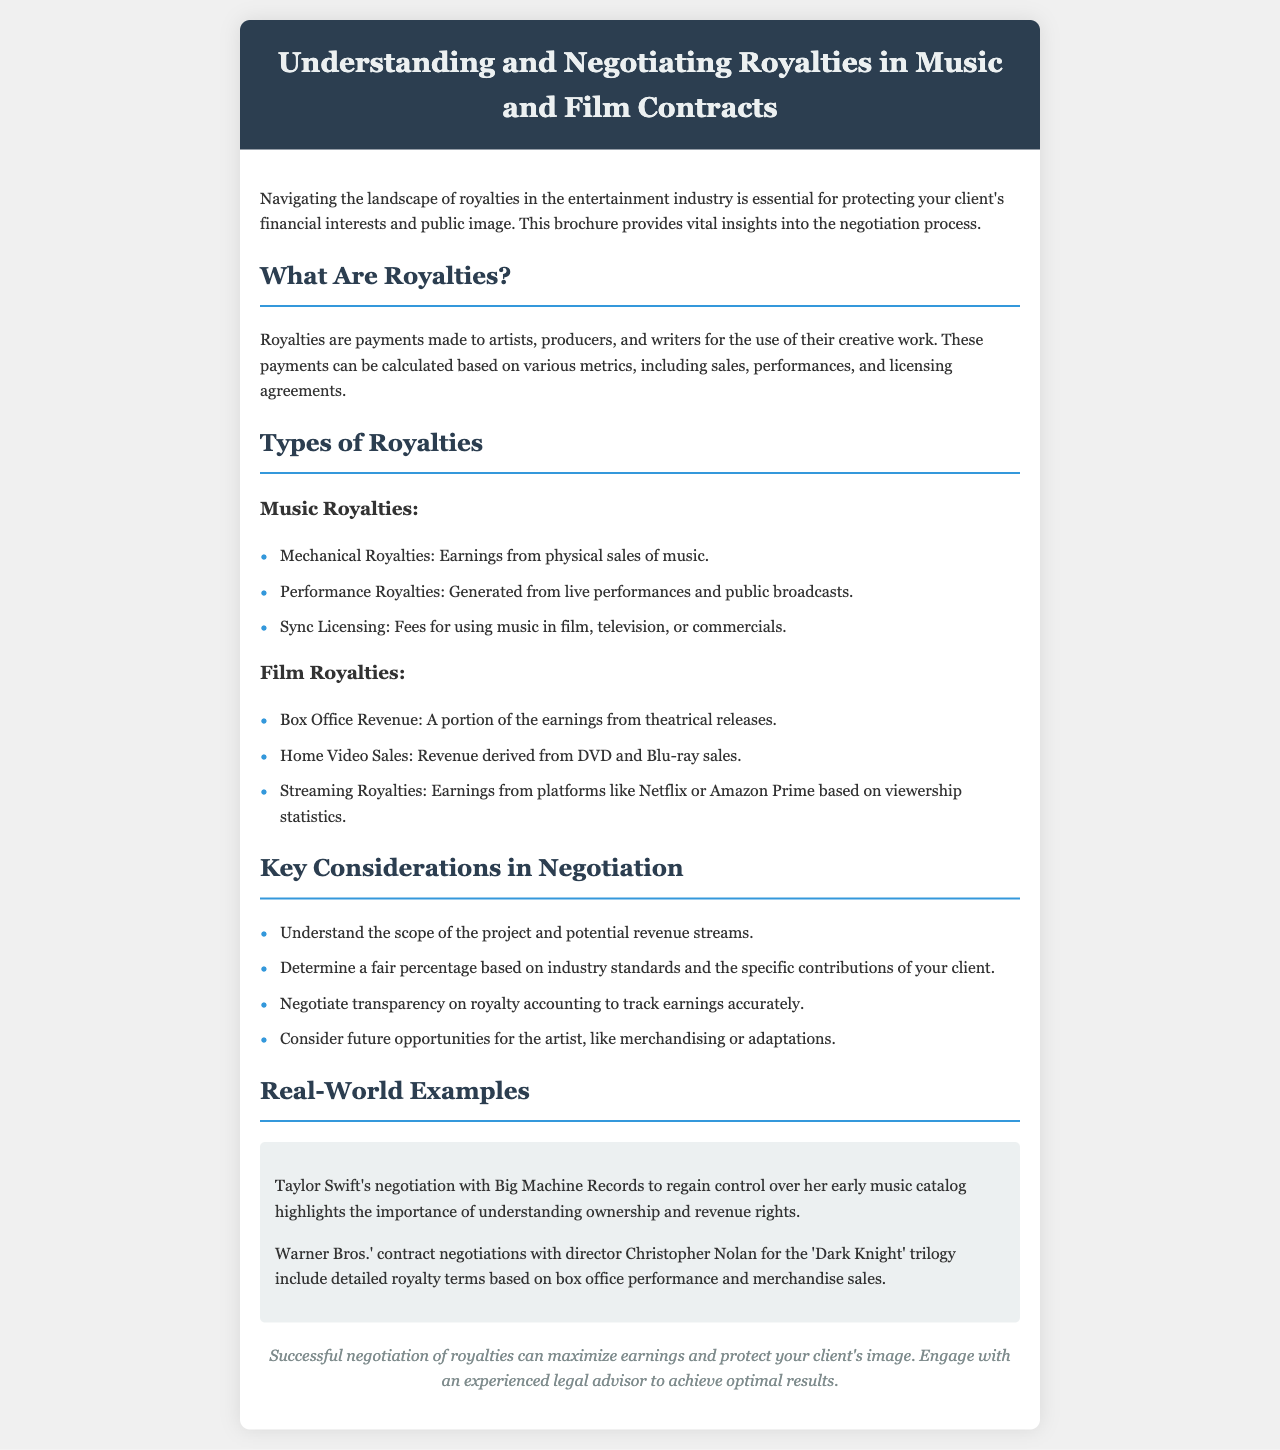What are royalties? Royalties are payments made to artists, producers, and writers for the use of their creative work.
Answer: Payments for creative work What are mechanical royalties? Mechanical royalties are earnings from physical sales of music.
Answer: Earnings from physical sales What is a key consideration in negotiation? One key consideration is to understand the scope of the project and potential revenue streams.
Answer: Scope of the project Who negotiated with Big Machine Records? Taylor Swift negotiated with Big Machine Records.
Answer: Taylor Swift What are streaming royalties based on? Streaming royalties are based on viewership statistics.
Answer: Viewership statistics How many types of royalties are listed in the brochure? There are six types of royalties listed in the brochure.
Answer: Six types 